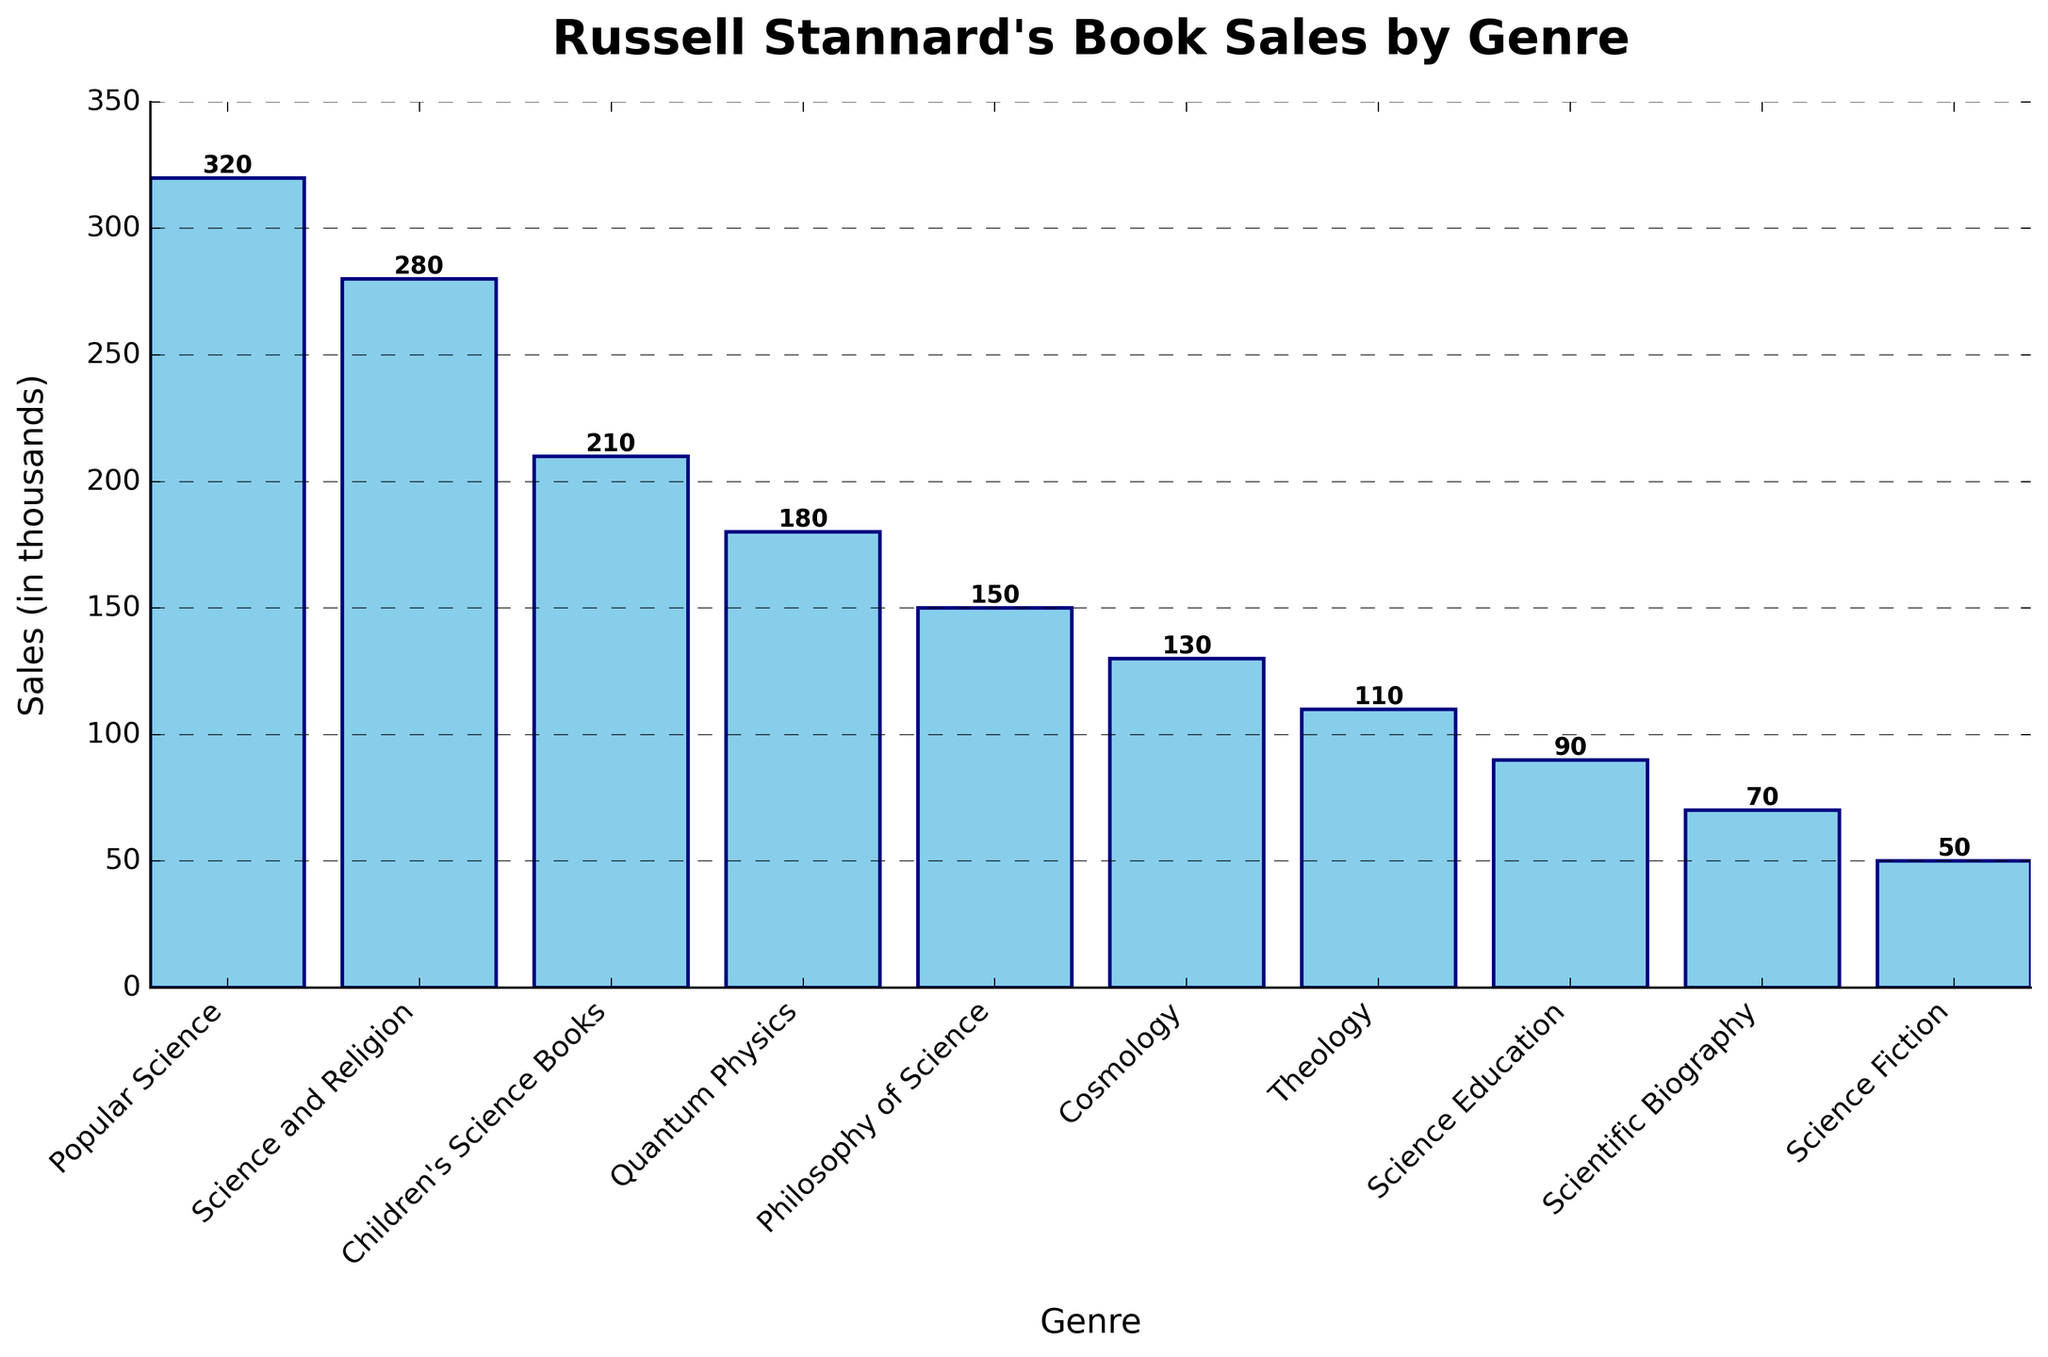What genre has the highest book sales? The bar for 'Popular Science' is the tallest, indicating it has the highest sales among the genres listed.
Answer: Popular Science What is the total sales for the genres 'Science and Religion' and 'Children's Science Books'? The sales for 'Science and Religion' is 280,000 and the sales for 'Children's Science Books' is 210,000. Summing these up, 280 + 210 = 490.
Answer: 490,000 Which genre has the lowest sales, and what is the value? The shortest bar corresponds to 'Science Fiction', which has the lowest sales. The height of this bar is labeled as 50,000.
Answer: Science Fiction, 50,000 What is the approximate difference in sales between 'Cosmology' and 'Science Education'? The sales for 'Cosmology' is 130,000 and the sales for 'Science Education' is 90,000. The difference is found by subtracting these values, 130 - 90 = 40.
Answer: 40,000 Are the total sales for 'Quantum Physics' and 'Theology' greater than the sales for 'Popular Science'? The sales for 'Quantum Physics' is 180,000 and 'Theology' is 110,000. Summing these, 180 + 110 = 290. The sales for 'Popular Science' is 320,000. Since 290,000 is less than 320,000, the answer is no.
Answer: No How much more did 'Popular Science' sell compared to 'Quantum Physics'? 'Popular Science' sold 320,000 and 'Quantum Physics' sold 180,000. The difference is 320 - 180 = 140.
Answer: 140,000 What is the combined sales of the top three genres? The top three genres are 'Popular Science' (320,000), 'Science and Religion' (280,000), and 'Children's Science Books' (210,000). Adding these values together, 320 + 280 + 210 = 810.
Answer: 810,000 Which genres sold more than 200,000 copies? The bars for 'Popular Science' (320,000), 'Science and Religion' (280,000), and 'Children's Science Books' (210,000) are all above 200,000.
Answer: Popular Science, Science and Religion, Children's Science Books Compare the sales of 'Philosophy of Science' and 'Scientific Biography'. Which one sold more, and by how much? 'Philosophy of Science' sold 150,000 and 'Scientific Biography' sold 70,000. The difference is 150 - 70 = 80, so 'Philosophy of Science' sold 80,000 more.
Answer: Philosophy of Science, 80,000 What is the average sales value across all genres? The total sales across all genres can be calculated by adding the individual sales (320 + 280 + 210 + 180 + 150 + 130 + 110 + 90 + 70 + 50 = 1590). There are 10 genres, so the average is 1590 / 10 = 159.
Answer: 159,000 